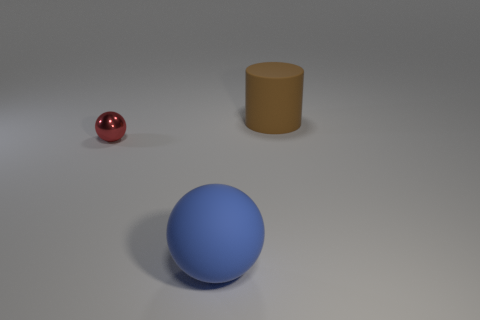Is there anything else that is the same size as the metallic thing?
Provide a short and direct response. No. What is the shape of the matte object right of the large blue rubber object?
Ensure brevity in your answer.  Cylinder. How many metallic objects are on the left side of the big thing that is in front of the rubber thing behind the big sphere?
Ensure brevity in your answer.  1. There is a rubber sphere; does it have the same size as the matte thing that is behind the red shiny thing?
Ensure brevity in your answer.  Yes. How big is the matte thing that is behind the big rubber thing in front of the small metallic ball?
Offer a very short reply. Large. How many objects are the same material as the cylinder?
Provide a short and direct response. 1. Is there a big green cube?
Ensure brevity in your answer.  No. How big is the object on the left side of the rubber sphere?
Provide a short and direct response. Small. What number of spheres are either small cyan matte objects or large blue things?
Your answer should be very brief. 1. What is the shape of the thing that is both on the left side of the big brown matte thing and to the right of the metal ball?
Your response must be concise. Sphere. 